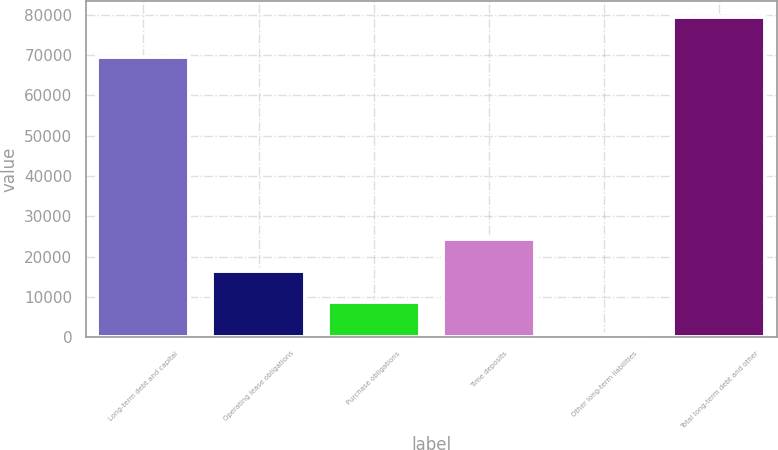Convert chart to OTSL. <chart><loc_0><loc_0><loc_500><loc_500><bar_chart><fcel>Long-term debt and capital<fcel>Operating lease obligations<fcel>Purchase obligations<fcel>Time deposits<fcel>Other long-term liabilities<fcel>Total long-term debt and other<nl><fcel>69539<fcel>16527.6<fcel>8648.8<fcel>24406.4<fcel>770<fcel>79558<nl></chart> 